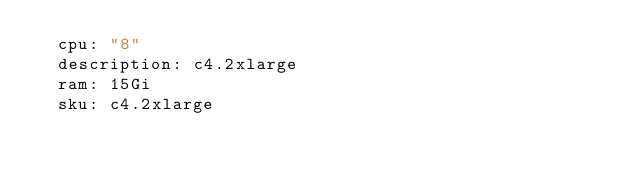<code> <loc_0><loc_0><loc_500><loc_500><_YAML_>  cpu: "8"
  description: c4.2xlarge
  ram: 15Gi
  sku: c4.2xlarge
</code> 